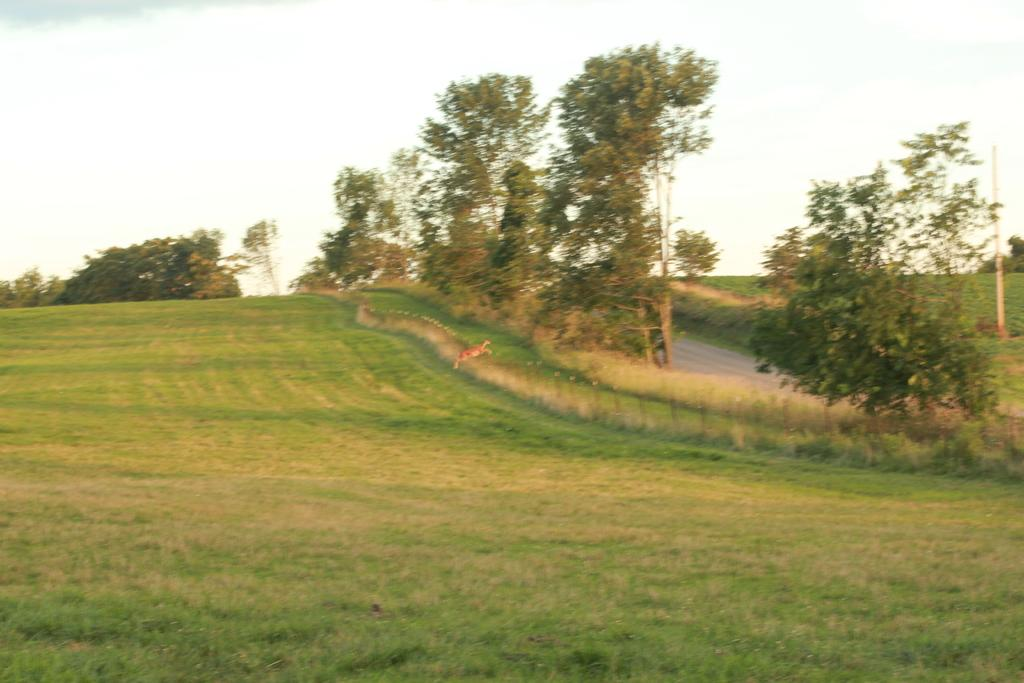What type of vegetation can be seen in the image? There is grass in the image. What structure is present in the image? There is a fence in the image. What type of living creature is in the image? There is an animal in the image. What other natural elements are present in the image? There are trees in the image. What is visible in the background of the image? The sky is visible in the image. How many sisters are present in the image? There are no sisters mentioned or visible in the image. What type of salt can be seen on the animal in the image? There is no salt present in the image, and the animal is not mentioned to have any. 